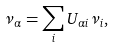Convert formula to latex. <formula><loc_0><loc_0><loc_500><loc_500>\nu _ { \alpha } = \sum _ { i } U _ { \alpha i } \nu _ { i } ,</formula> 